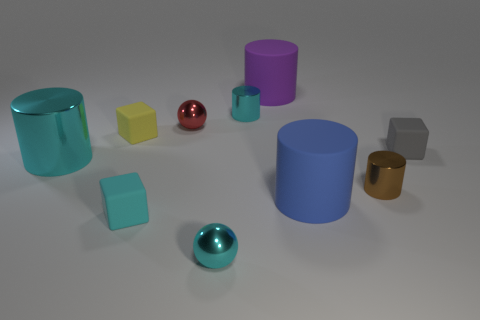Are there fewer metallic spheres on the left side of the tiny gray object than tiny metallic things?
Ensure brevity in your answer.  Yes. Are there any blue blocks of the same size as the brown shiny object?
Give a very brief answer. No. There is a large metal thing; is it the same color as the ball in front of the tiny gray cube?
Keep it short and to the point. Yes. How many large metal cylinders are to the left of the large cylinder that is to the left of the cyan shiny sphere?
Provide a succinct answer. 0. There is a tiny cube that is to the right of the sphere that is in front of the cyan matte object; what color is it?
Your answer should be very brief. Gray. There is a tiny thing that is in front of the small brown metallic cylinder and behind the tiny cyan metallic sphere; what is it made of?
Ensure brevity in your answer.  Rubber. Are there any cyan matte things that have the same shape as the small yellow thing?
Provide a succinct answer. Yes. There is a cyan thing that is on the left side of the tiny yellow cube; is it the same shape as the purple matte object?
Your response must be concise. Yes. What number of tiny metallic things are in front of the blue cylinder and behind the brown metal thing?
Offer a terse response. 0. What is the shape of the tiny metallic thing that is on the right side of the purple object?
Ensure brevity in your answer.  Cylinder. 